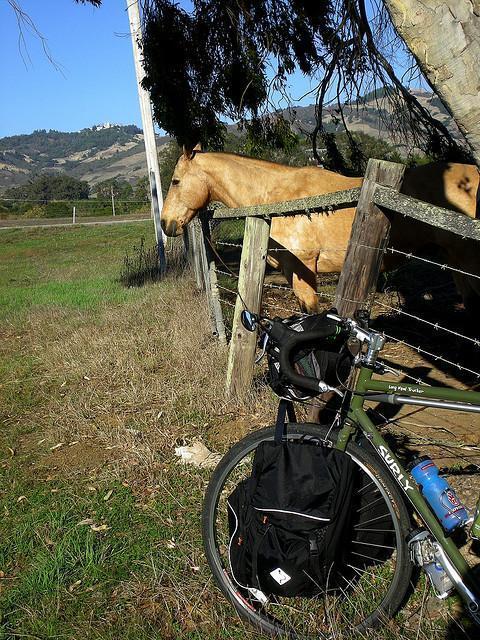How many benches are there?
Give a very brief answer. 0. 